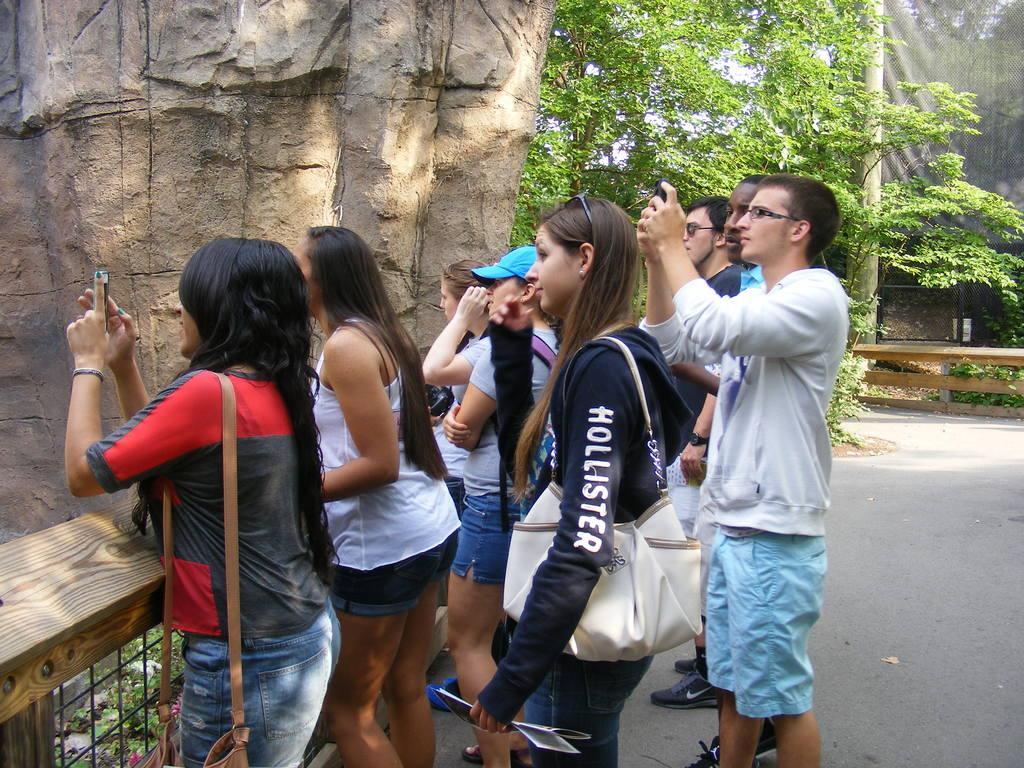Please provide a concise description of this image. In this image, I can see a group of people standing on the pathway. There are trees, fences, pole and a rock. 